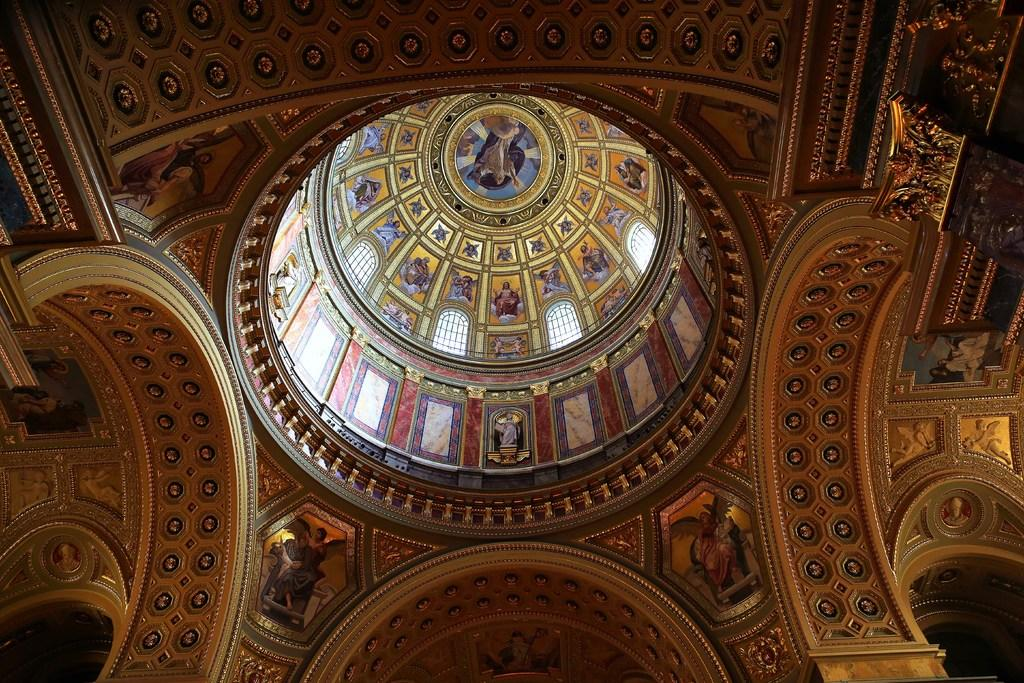What type of view is shown in the image? The image shows an internal view of the roof. What can be seen on the windows in the image? There are windows with a design in the image. What type of decorative elements are present in the image? Sculptures are present in the image. Can you see the ocean from the image? No, the image does not show any view of the ocean. 